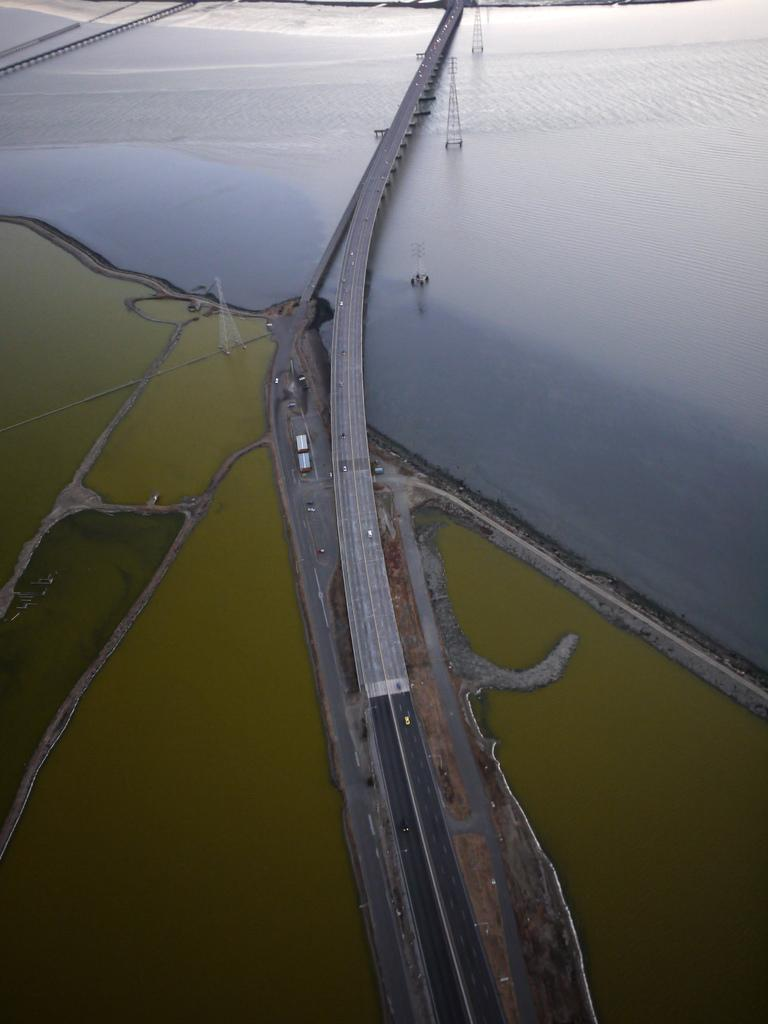What can be seen on the road in the image? There are vehicles on the road in the image. What structures are visible in the image? There are towers visible in the image. What natural element is present in the image? There is water visible in the image. How many fingers can be seen pointing at the towers in the image? There are no fingers visible in the image, as it only features vehicles on the road, towers, and water. What type of bit is being used to extract information from the water in the image? There is no bit present in the image, as it only features vehicles on the road, towers, and water. 